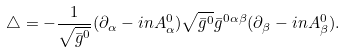Convert formula to latex. <formula><loc_0><loc_0><loc_500><loc_500>\triangle = - \frac { 1 } { \sqrt { \bar { g } ^ { 0 } } } ( \partial _ { \alpha } - i n A _ { \alpha } ^ { 0 } ) \sqrt { \bar { g } ^ { 0 } } \bar { g } ^ { 0 \alpha \beta } ( \partial _ { \beta } - i n A _ { \beta } ^ { 0 } ) .</formula> 